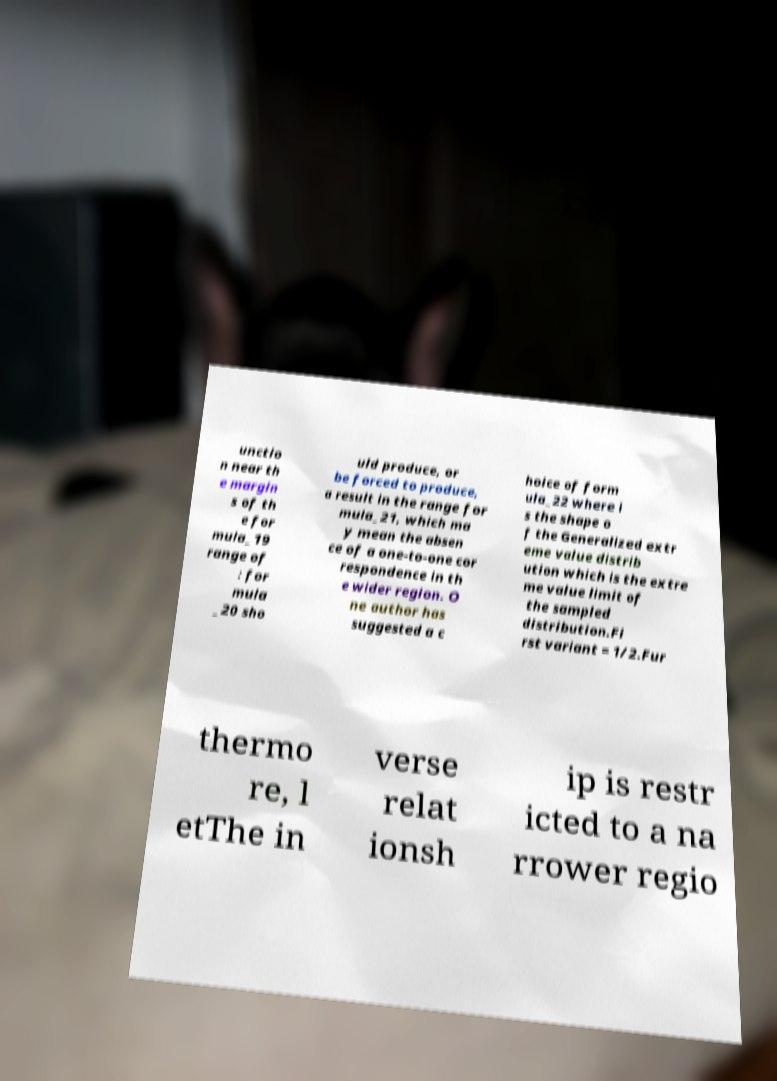Please identify and transcribe the text found in this image. unctio n near th e margin s of th e for mula_19 range of : for mula _20 sho uld produce, or be forced to produce, a result in the range for mula_21, which ma y mean the absen ce of a one-to-one cor respondence in th e wider region. O ne author has suggested a c hoice of form ula_22 where i s the shape o f the Generalized extr eme value distrib ution which is the extre me value limit of the sampled distribution.Fi rst variant = 1/2.Fur thermo re, l etThe in verse relat ionsh ip is restr icted to a na rrower regio 